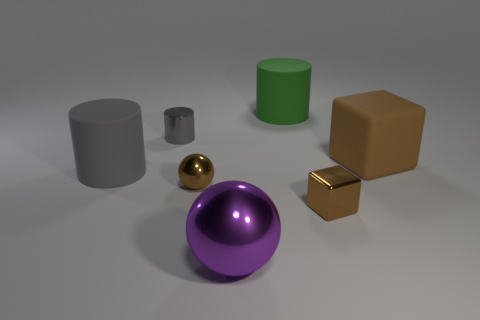What number of large cylinders are both to the left of the tiny cylinder and behind the gray rubber object?
Your answer should be compact. 0. The brown matte thing that is the same size as the purple metallic object is what shape?
Make the answer very short. Cube. Are there any large green cylinders on the right side of the big cylinder behind the gray object behind the large gray matte cylinder?
Provide a short and direct response. No. Does the metal cylinder have the same color as the large matte cylinder in front of the big brown matte cube?
Make the answer very short. Yes. What number of small shiny balls have the same color as the small shiny block?
Offer a very short reply. 1. What is the size of the green cylinder that is behind the large object that is to the left of the small gray thing?
Offer a very short reply. Large. What number of objects are either matte cylinders in front of the big brown rubber cube or big blue metallic spheres?
Your answer should be compact. 1. Is there a green metal thing that has the same size as the purple object?
Provide a succinct answer. No. Are there any big gray rubber things that are on the right side of the matte cylinder that is to the left of the big metal object?
Give a very brief answer. No. What number of cylinders are either cyan objects or brown metal objects?
Your answer should be compact. 0. 